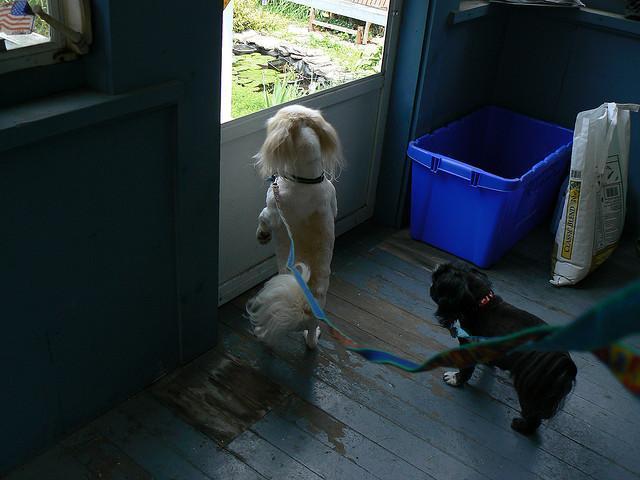How many dogs are pictured?
Give a very brief answer. 2. How many dogs can you see?
Give a very brief answer. 2. How many people are sitting on chair?
Give a very brief answer. 0. 